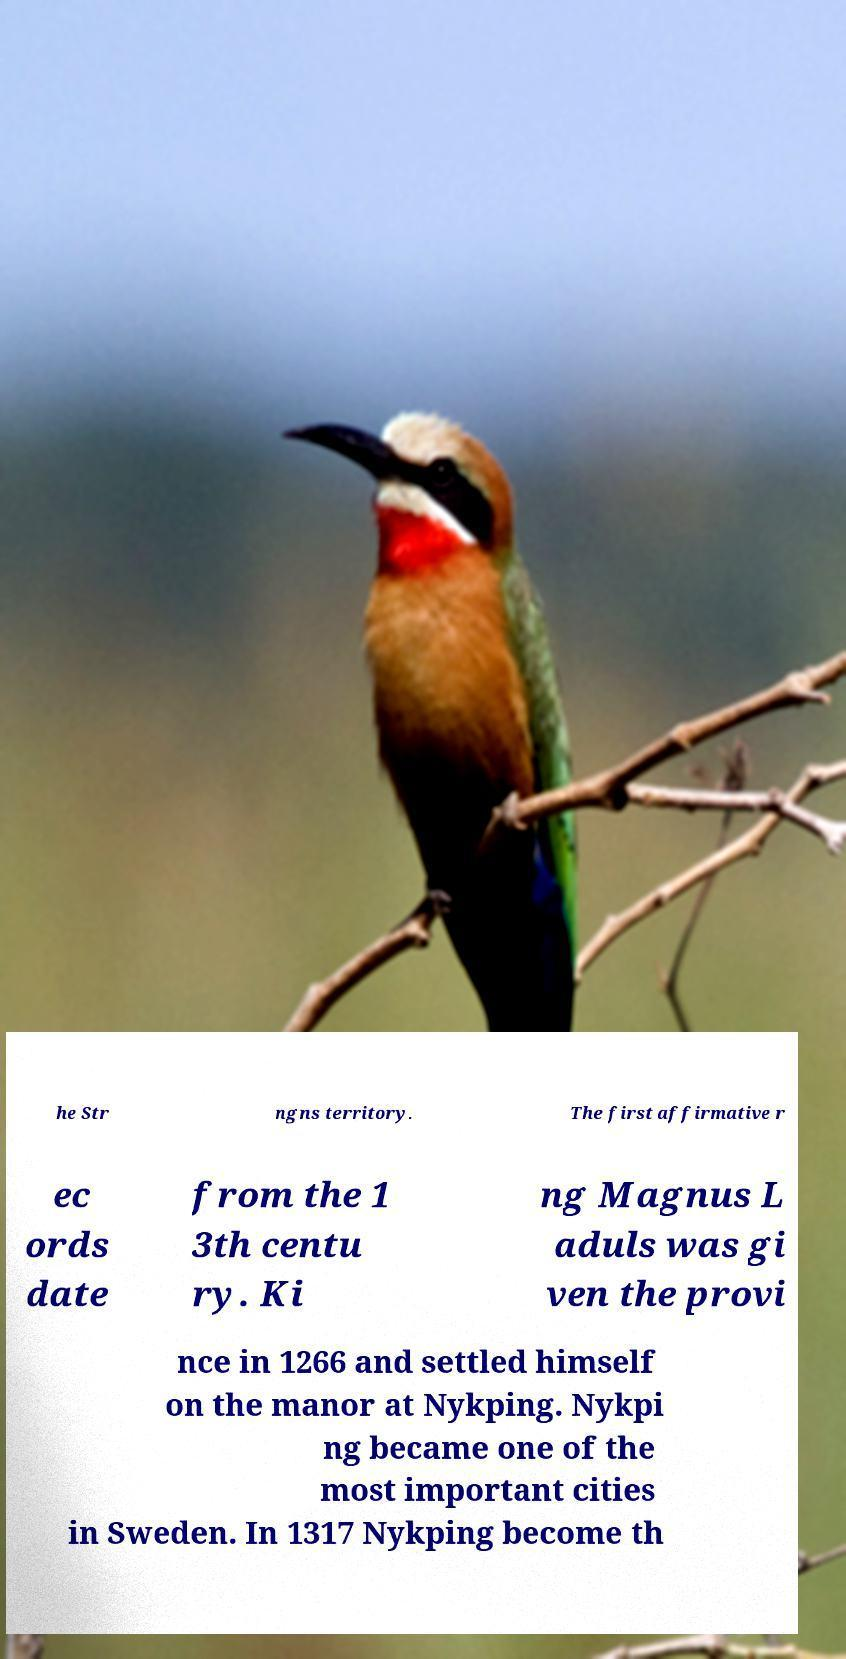What messages or text are displayed in this image? I need them in a readable, typed format. he Str ngns territory. The first affirmative r ec ords date from the 1 3th centu ry. Ki ng Magnus L aduls was gi ven the provi nce in 1266 and settled himself on the manor at Nykping. Nykpi ng became one of the most important cities in Sweden. In 1317 Nykping become th 